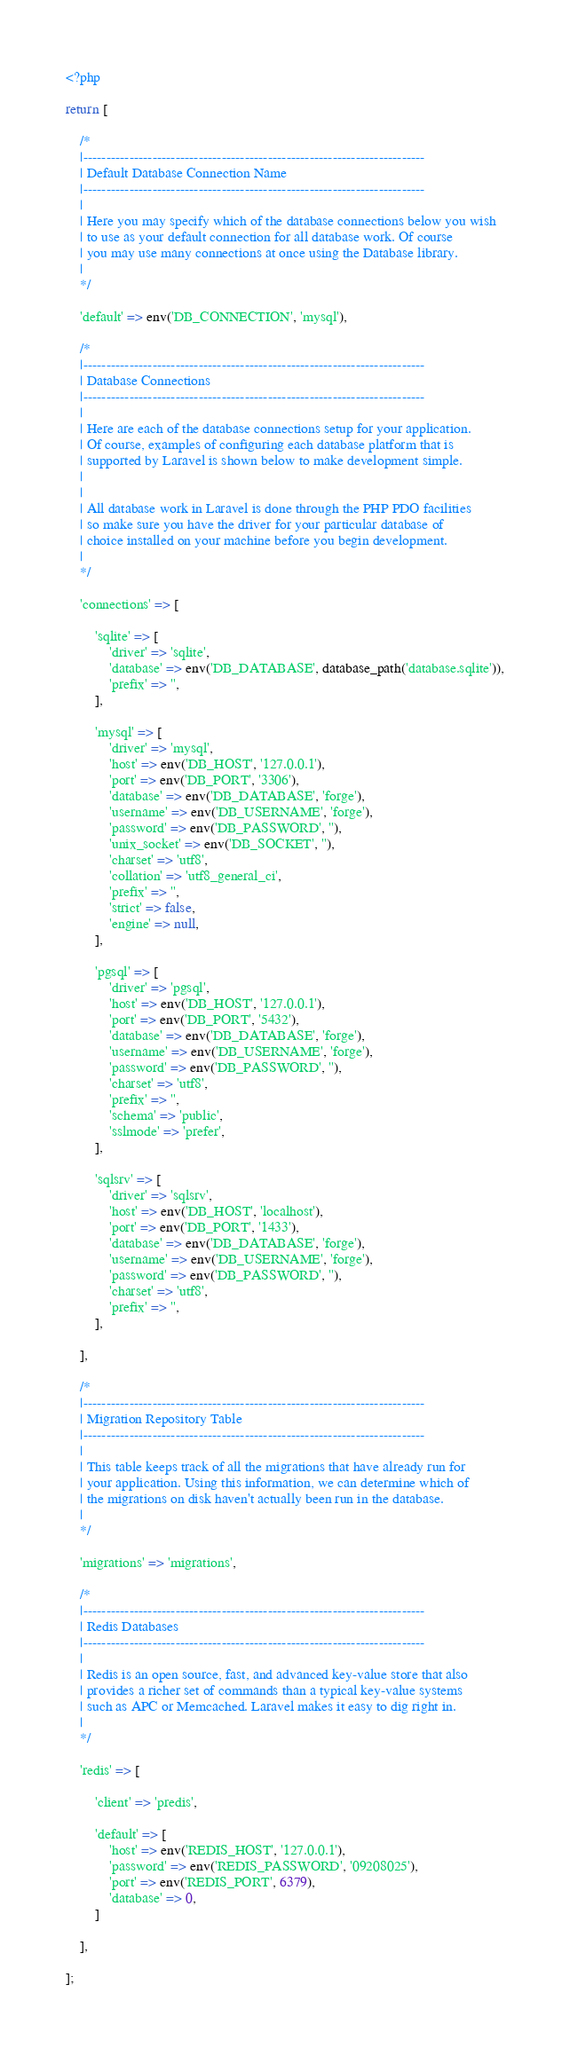<code> <loc_0><loc_0><loc_500><loc_500><_PHP_><?php

return [

    /*
    |--------------------------------------------------------------------------
    | Default Database Connection Name
    |--------------------------------------------------------------------------
    |
    | Here you may specify which of the database connections below you wish
    | to use as your default connection for all database work. Of course
    | you may use many connections at once using the Database library.
    |
    */

    'default' => env('DB_CONNECTION', 'mysql'),

    /*
    |--------------------------------------------------------------------------
    | Database Connections
    |--------------------------------------------------------------------------
    |
    | Here are each of the database connections setup for your application.
    | Of course, examples of configuring each database platform that is
    | supported by Laravel is shown below to make development simple.
    |
    |
    | All database work in Laravel is done through the PHP PDO facilities
    | so make sure you have the driver for your particular database of
    | choice installed on your machine before you begin development.
    |
    */

    'connections' => [

        'sqlite' => [
            'driver' => 'sqlite',
            'database' => env('DB_DATABASE', database_path('database.sqlite')),
            'prefix' => '',
        ],

        'mysql' => [
            'driver' => 'mysql',
            'host' => env('DB_HOST', '127.0.0.1'),
            'port' => env('DB_PORT', '3306'),
            'database' => env('DB_DATABASE', 'forge'),
            'username' => env('DB_USERNAME', 'forge'),
            'password' => env('DB_PASSWORD', ''),
            'unix_socket' => env('DB_SOCKET', ''),
            'charset' => 'utf8',
            'collation' => 'utf8_general_ci',
            'prefix' => '',
            'strict' => false,
            'engine' => null,
        ],

        'pgsql' => [
            'driver' => 'pgsql',
            'host' => env('DB_HOST', '127.0.0.1'),
            'port' => env('DB_PORT', '5432'),
            'database' => env('DB_DATABASE', 'forge'),
            'username' => env('DB_USERNAME', 'forge'),
            'password' => env('DB_PASSWORD', ''),
            'charset' => 'utf8',
            'prefix' => '',
            'schema' => 'public',
            'sslmode' => 'prefer',
        ],

        'sqlsrv' => [
            'driver' => 'sqlsrv',
            'host' => env('DB_HOST', 'localhost'),
            'port' => env('DB_PORT', '1433'),
            'database' => env('DB_DATABASE', 'forge'),
            'username' => env('DB_USERNAME', 'forge'),
            'password' => env('DB_PASSWORD', ''),
            'charset' => 'utf8',
            'prefix' => '',
        ],

    ],

    /*
    |--------------------------------------------------------------------------
    | Migration Repository Table
    |--------------------------------------------------------------------------
    |
    | This table keeps track of all the migrations that have already run for
    | your application. Using this information, we can determine which of
    | the migrations on disk haven't actually been run in the database.
    |
    */

    'migrations' => 'migrations',

    /*
    |--------------------------------------------------------------------------
    | Redis Databases
    |--------------------------------------------------------------------------
    |
    | Redis is an open source, fast, and advanced key-value store that also
    | provides a richer set of commands than a typical key-value systems
    | such as APC or Memcached. Laravel makes it easy to dig right in.
    |
    */

    'redis' => [

        'client' => 'predis',

        'default' => [
            'host' => env('REDIS_HOST', '127.0.0.1'),
            'password' => env('REDIS_PASSWORD', '09208025'),
            'port' => env('REDIS_PORT', 6379),
            'database' => 0,
        ]

    ],

];
</code> 